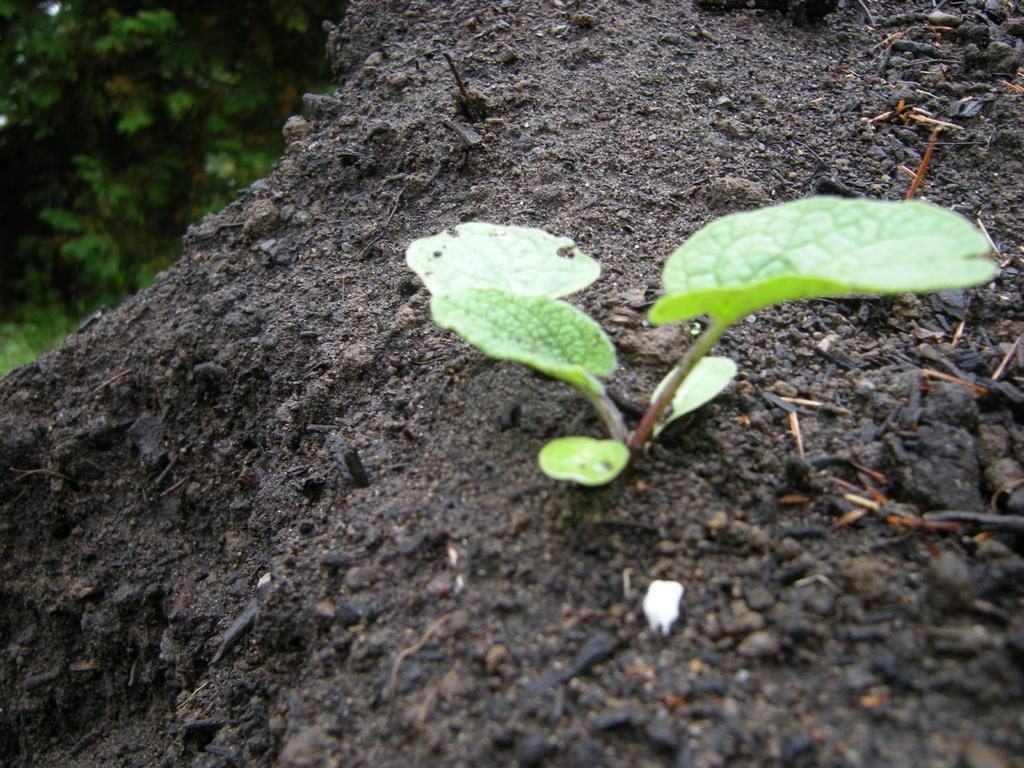What is the main subject of the image? There is a plant in the image. What color is the plant? The plant is green in color. How is the plant positioned in the image? The plant is in soil. What color is the soil? The soil is black in color. What can be seen in the background of the image? There are trees in the background of the image. What type of sound does the flame make in the image? There is no flame present in the image, so it cannot make any sound. 